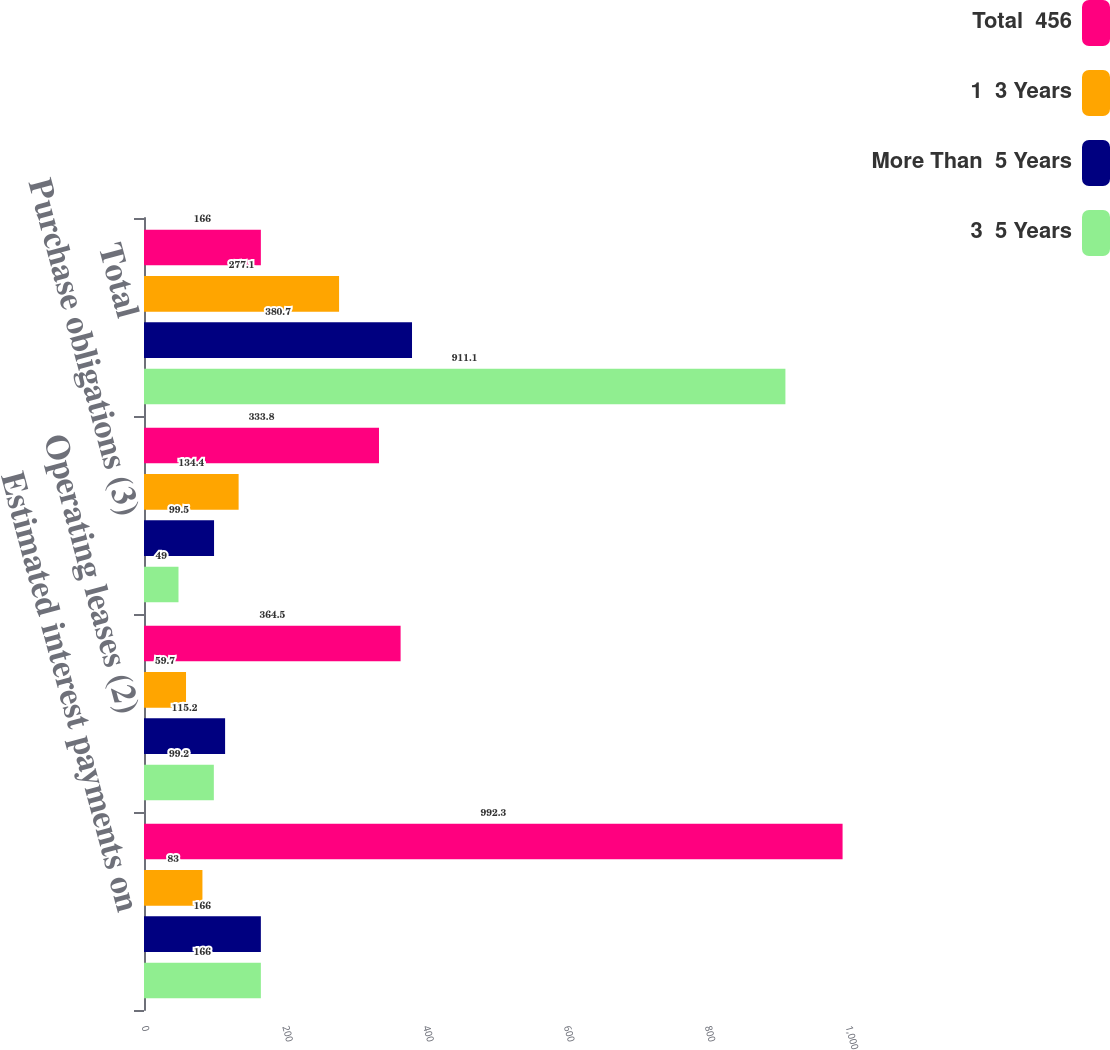Convert chart. <chart><loc_0><loc_0><loc_500><loc_500><stacked_bar_chart><ecel><fcel>Estimated interest payments on<fcel>Operating leases (2)<fcel>Purchase obligations (3)<fcel>Total<nl><fcel>Total  456<fcel>992.3<fcel>364.5<fcel>333.8<fcel>166<nl><fcel>1  3 Years<fcel>83<fcel>59.7<fcel>134.4<fcel>277.1<nl><fcel>More Than  5 Years<fcel>166<fcel>115.2<fcel>99.5<fcel>380.7<nl><fcel>3  5 Years<fcel>166<fcel>99.2<fcel>49<fcel>911.1<nl></chart> 